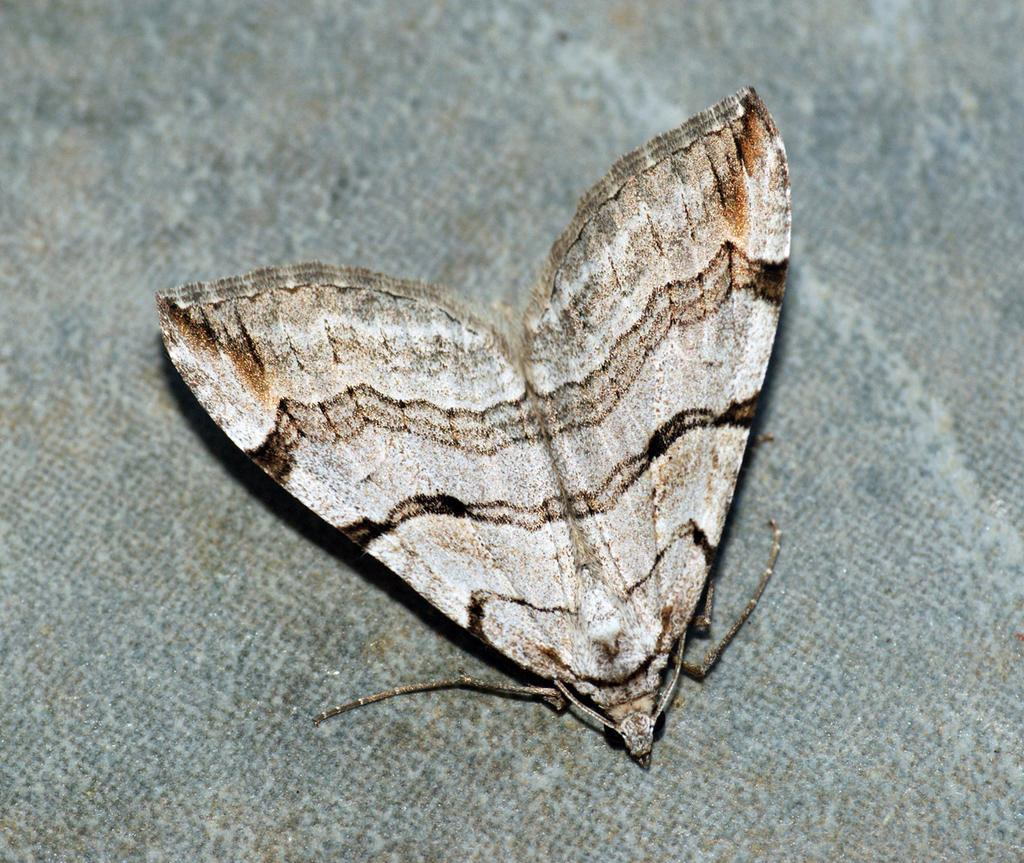What is the main subject in the middle of the image? There is a moth in the middle of the image. What can be seen at the bottom of the image? The bottom of the image appears to be a floor. What type of cactus is present in the image? There is no cactus present in the image; it features a moth and a floor. Is there any mention of a birthday celebration in the image? There is no reference to a birthday celebration in the image. 